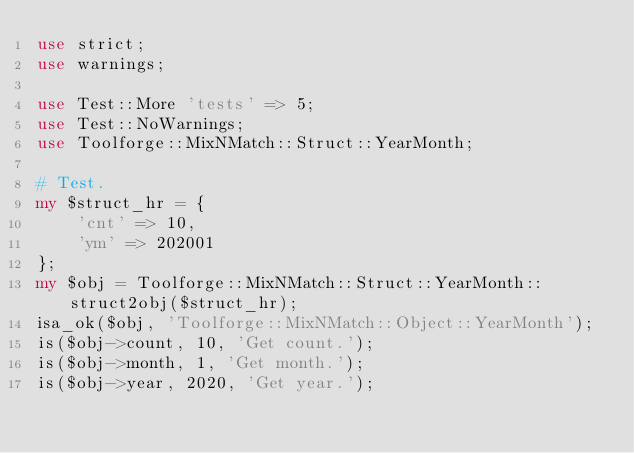<code> <loc_0><loc_0><loc_500><loc_500><_Perl_>use strict;
use warnings;

use Test::More 'tests' => 5;
use Test::NoWarnings;
use Toolforge::MixNMatch::Struct::YearMonth;

# Test.
my $struct_hr = {
	'cnt' => 10,
	'ym' => 202001
};
my $obj = Toolforge::MixNMatch::Struct::YearMonth::struct2obj($struct_hr);
isa_ok($obj, 'Toolforge::MixNMatch::Object::YearMonth');
is($obj->count, 10, 'Get count.');
is($obj->month, 1, 'Get month.');
is($obj->year, 2020, 'Get year.');
</code> 